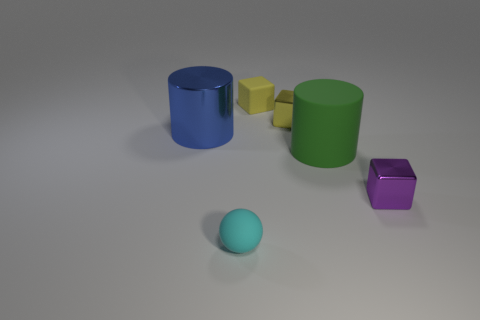How many yellow cubes must be subtracted to get 1 yellow cubes? 1 Subtract all small yellow blocks. How many blocks are left? 1 Add 1 blue cylinders. How many objects exist? 7 Subtract all yellow blocks. How many blocks are left? 1 Subtract 2 cubes. How many cubes are left? 1 Subtract all brown cylinders. How many yellow blocks are left? 2 Subtract all spheres. How many objects are left? 5 Subtract all yellow rubber blocks. Subtract all tiny red objects. How many objects are left? 5 Add 1 tiny yellow metal cubes. How many tiny yellow metal cubes are left? 2 Add 5 big matte things. How many big matte things exist? 6 